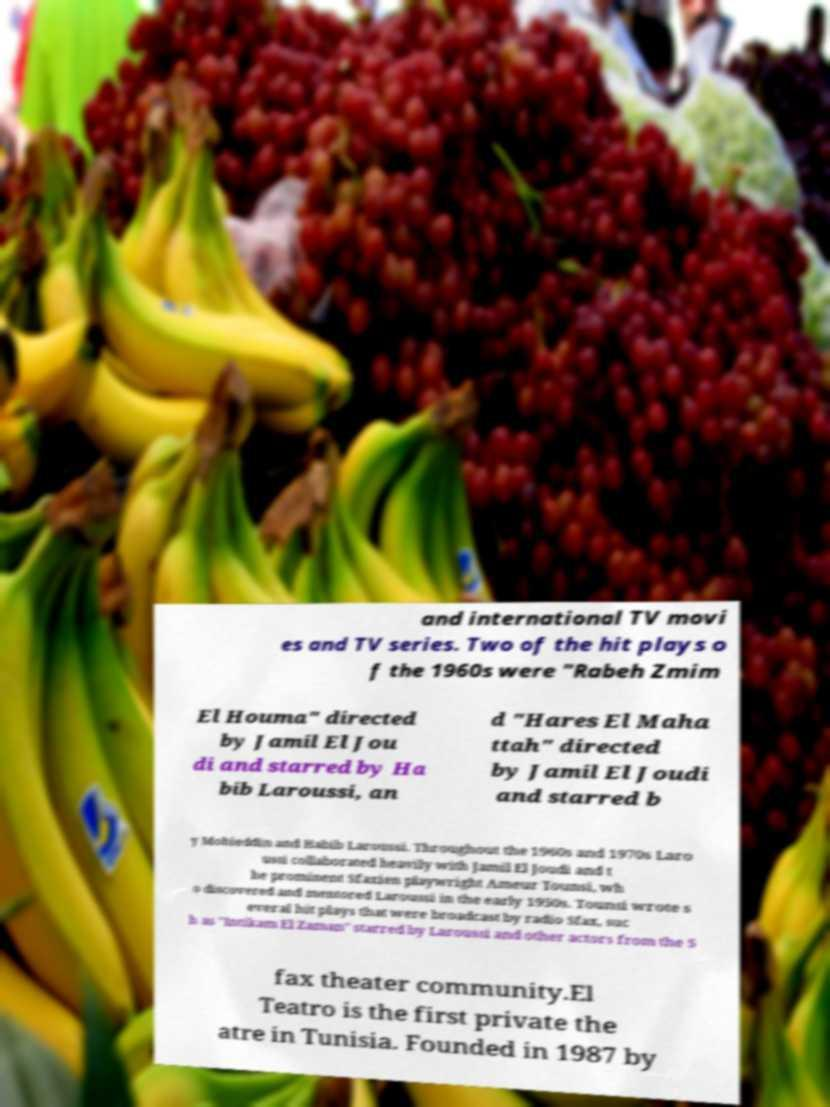Please read and relay the text visible in this image. What does it say? and international TV movi es and TV series. Two of the hit plays o f the 1960s were "Rabeh Zmim El Houma" directed by Jamil El Jou di and starred by Ha bib Laroussi, an d "Hares El Maha ttah" directed by Jamil El Joudi and starred b y Mohieddin and Habib Laroussi. Throughout the 1960s and 1970s Laro ussi collaborated heavily with Jamil El Joudi and t he prominent Sfaxien playwright Ameur Tounsi, wh o discovered and mentored Laroussi in the early 1950s. Tounsi wrote s everal hit plays that were broadcast by radio Sfax, suc h as "Intikam El Zaman" starred by Laroussi and other actors from the S fax theater community.El Teatro is the first private the atre in Tunisia. Founded in 1987 by 